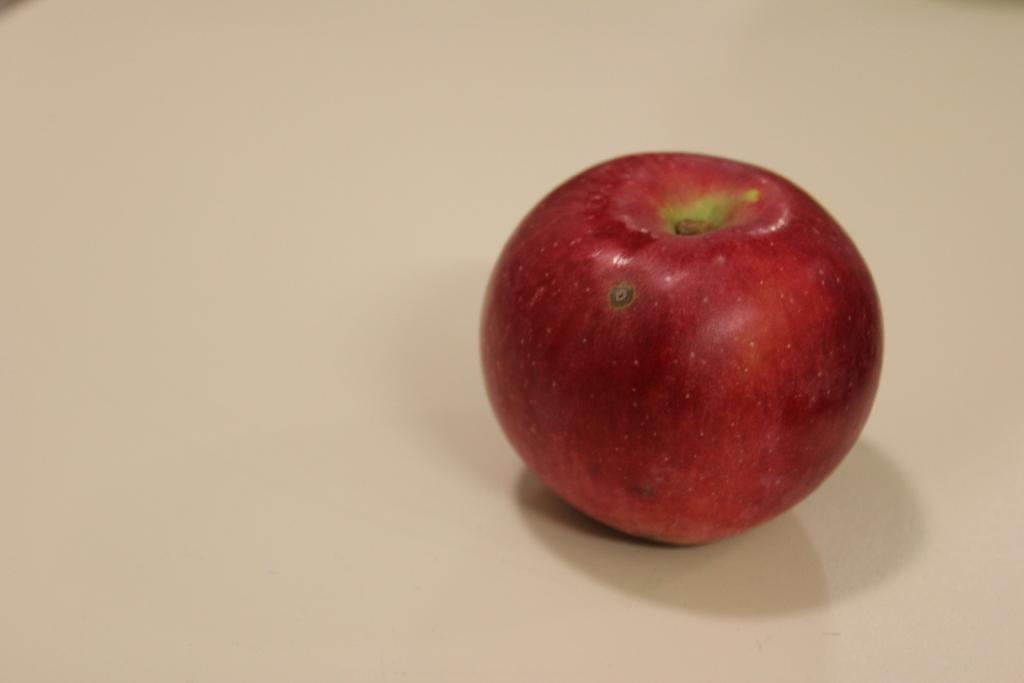What is the main subject of the picture? The main subject of the picture is an apple. Can you describe the surface on which the apple might be placed? The apple might be placed on a table. What color is the background of the image? The background of the image is white in color. What type of structure is being celebrated in the image? There is no structure or celebration present in the image; it features an apple on a white background. What territory is depicted in the image? There is no territory depicted in the image; it features an apple on a white background. 